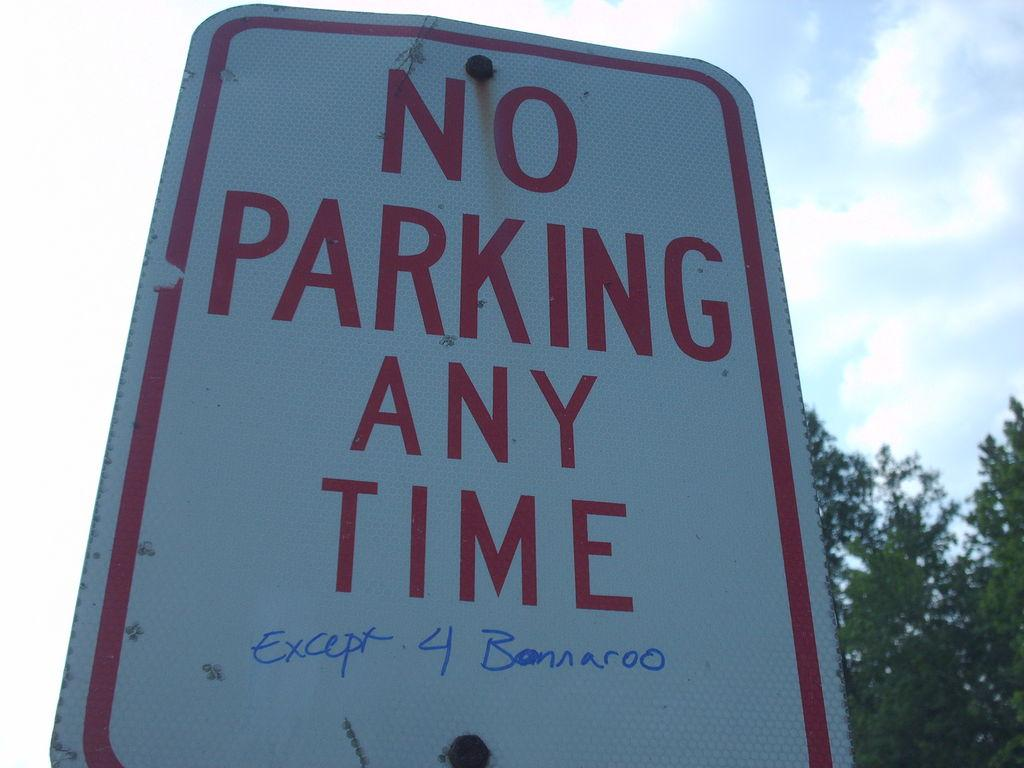Provide a one-sentence caption for the provided image. A sign that indicates no parking at any time. 